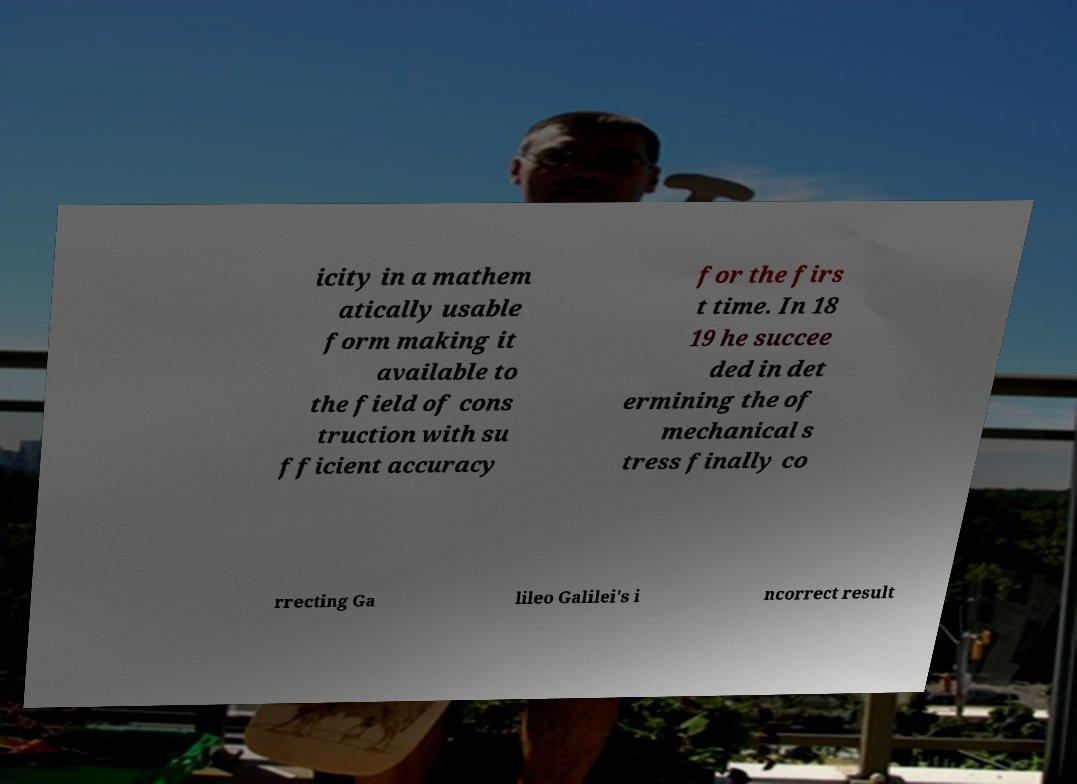Could you assist in decoding the text presented in this image and type it out clearly? icity in a mathem atically usable form making it available to the field of cons truction with su fficient accuracy for the firs t time. In 18 19 he succee ded in det ermining the of mechanical s tress finally co rrecting Ga lileo Galilei's i ncorrect result 